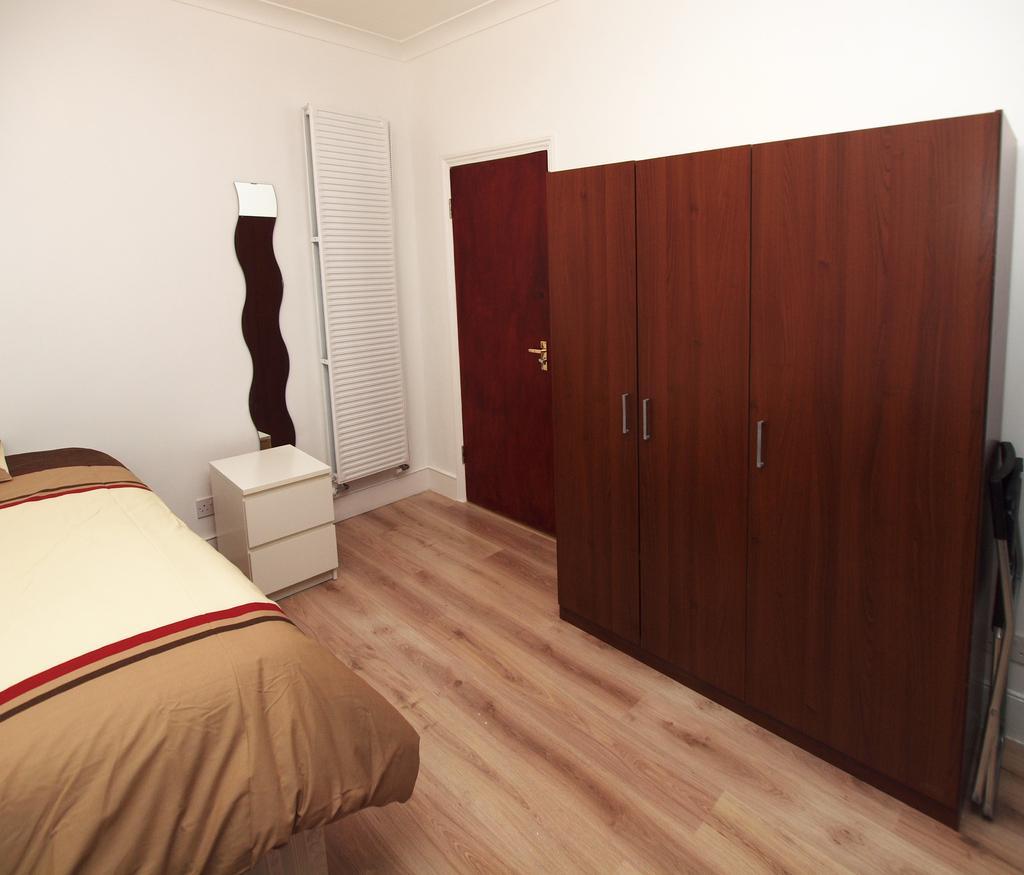Please provide a concise description of this image. This image is taken inside a room. To the left side of the image there is bed. In the background of the image there is wall. There is a table. There is a cupboard and wall. There is a door. At the bottom of the image there is wooden flooring. 